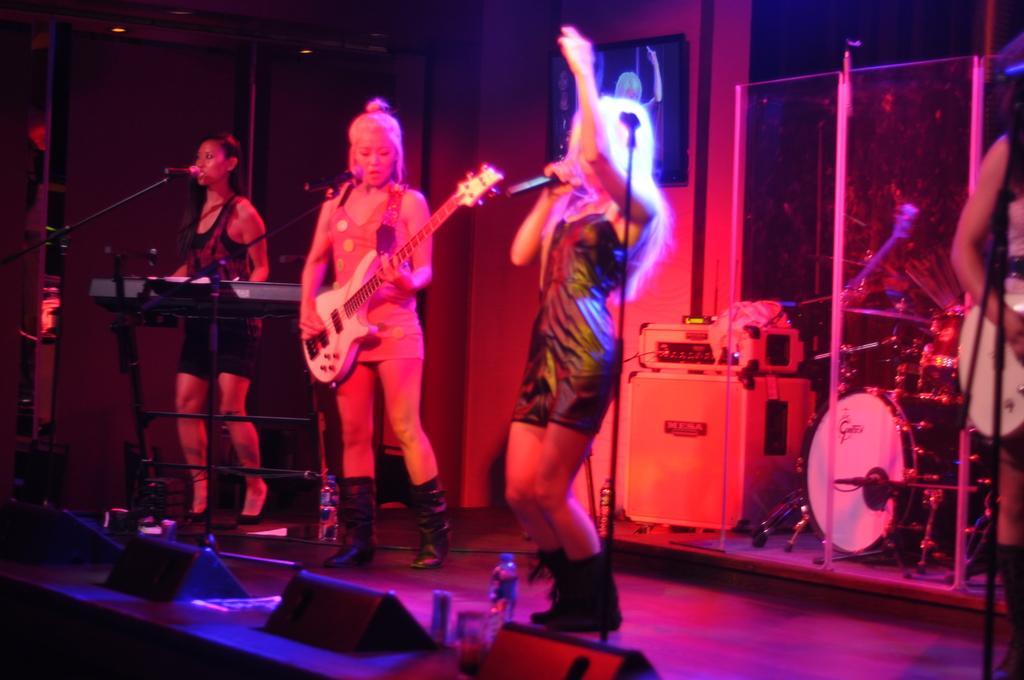Could you give a brief overview of what you see in this image? This is a music concert there are total four women, first woman is singing by playing a piano, second woman is playing a guitar,the third woman is singing , in the background we can see few drums and other instruments, trees, a glass, to the left there is a television which is displaying their actions. 